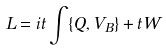Convert formula to latex. <formula><loc_0><loc_0><loc_500><loc_500>L = i t \int \{ Q , V _ { B } \} + t W</formula> 